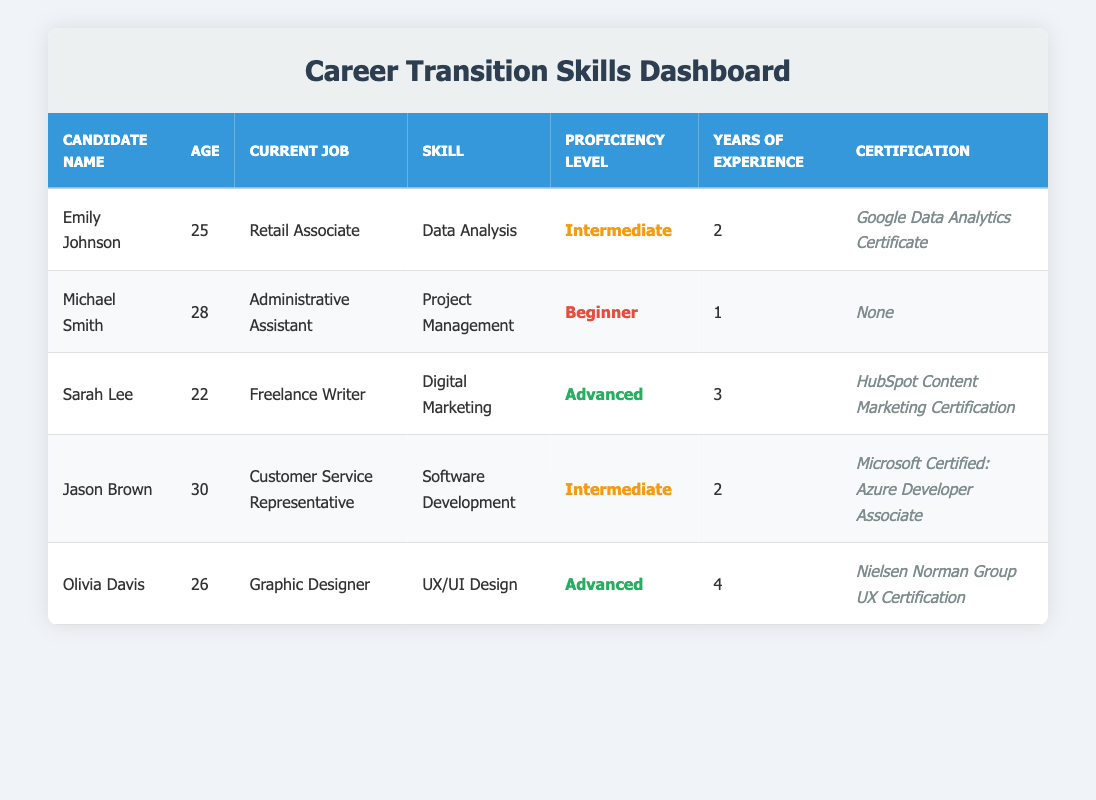What is the proficiency level of Sarah Lee? By locating Sarah Lee's row in the table, we see the "Proficiency Level" column entry for her is "Advanced."
Answer: Advanced How many years of experience does Michael Smith have? Looking at Michael Smith's row, we can find the "Years of Experience" column, which indicates he has 1 year of experience.
Answer: 1 What certification does Olivia Davis hold? In the table, Olivia Davis's row shows the "Certification" column, where it states she has the "Nielsen Norman Group UX Certification."
Answer: Nielsen Norman Group UX Certification How many candidates have an intermediate proficiency level? Checking the table for all candidates with "Intermediate" in the "Proficiency Level" column reveals Emily Johnson and Jason Brown, totaling 2 candidates.
Answer: 2 Is Sarah Lee's proficiency level higher than Jason Brown's? By comparing their proficiency levels, Sarah Lee is "Advanced" while Jason Brown is "Intermediate," confirming that Sarah Lee's proficiency is higher.
Answer: Yes Which skill has the highest proficiency level among the candidates? Analyzing the "Proficiency Level" column, both Sarah Lee and Olivia Davis have an "Advanced" level, indicating that their skills of "Digital Marketing" and "UX/UI Design" are the highest.
Answer: Digital Marketing and UX/UI Design What is the age difference between the oldest and youngest candidates? The oldest candidate is Jason Brown at 30 years and the youngest is Sarah Lee at 22 years. The age difference can be calculated as 30 - 22 = 8 years.
Answer: 8 True or False: Michael Smith has a certification related to his skill. Looking at Michael Smith’s row, it shows that he has "None" indicated in the "Certification" column, so it is false that he has a related certification.
Answer: False Which skill has the most years of experience among the candidates? In the table, Olivia Davis has 4 years of experience with "UX/UI Design," which is the highest compared to the others, who have 1 to 3 years.
Answer: UX/UI Design How many candidates currently work in jobs related to their skills? Observing the table, it appears that Olivia Davis (Graphic Designer - UX/UI Design) and Sarah Lee (Freelance Writer - Digital Marketing) hold jobs relevant to their skills, resulting in 2 candidates.
Answer: 2 